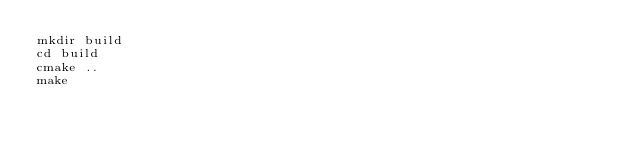<code> <loc_0><loc_0><loc_500><loc_500><_Bash_>mkdir build
cd build
cmake ..
make</code> 